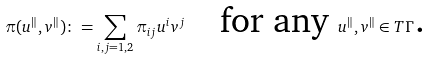Convert formula to latex. <formula><loc_0><loc_0><loc_500><loc_500>\pi ( u ^ { \| } , v ^ { \| } ) \colon = \sum _ { i , j = 1 , 2 } \pi _ { i j } u ^ { i } v ^ { j } \quad \text {for any } u ^ { \| } , v ^ { \| } \in T \Gamma \text {.}</formula> 